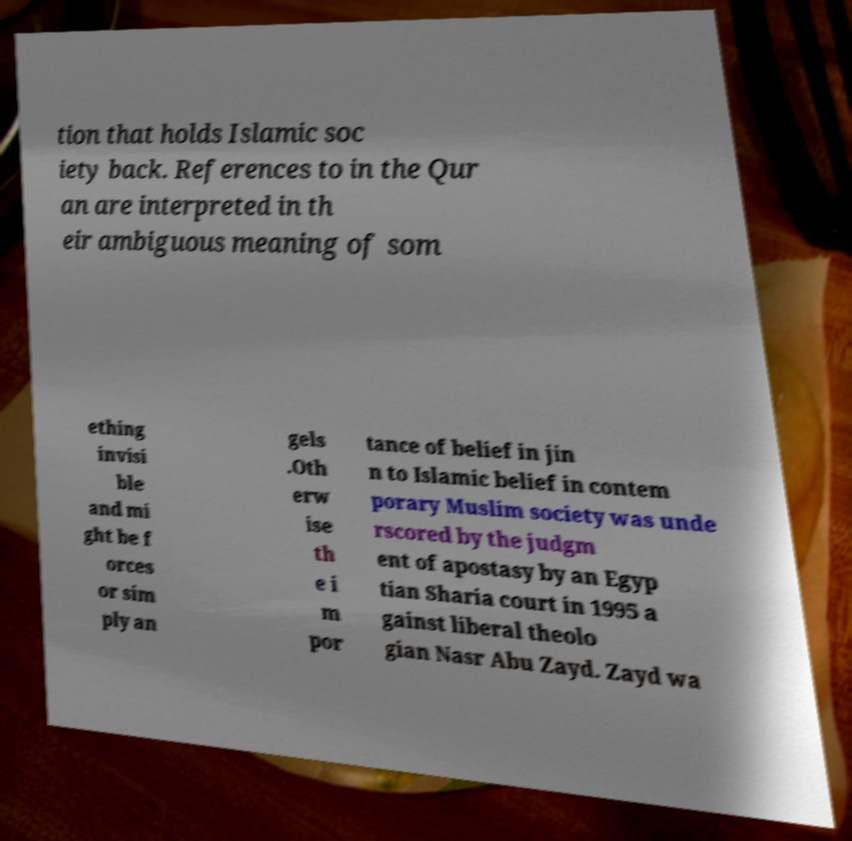Can you read and provide the text displayed in the image?This photo seems to have some interesting text. Can you extract and type it out for me? tion that holds Islamic soc iety back. References to in the Qur an are interpreted in th eir ambiguous meaning of som ething invisi ble and mi ght be f orces or sim ply an gels .Oth erw ise th e i m por tance of belief in jin n to Islamic belief in contem porary Muslim society was unde rscored by the judgm ent of apostasy by an Egyp tian Sharia court in 1995 a gainst liberal theolo gian Nasr Abu Zayd. Zayd wa 